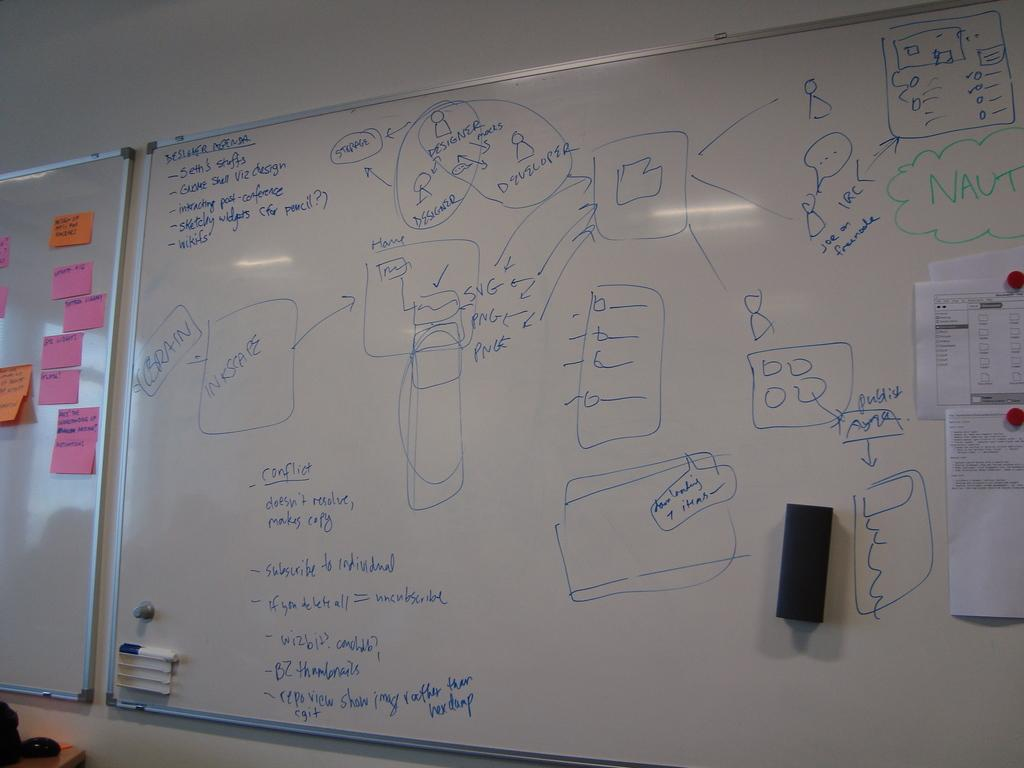<image>
Create a compact narrative representing the image presented. A large whiteboard has sayings all over it, including the word "designer" 